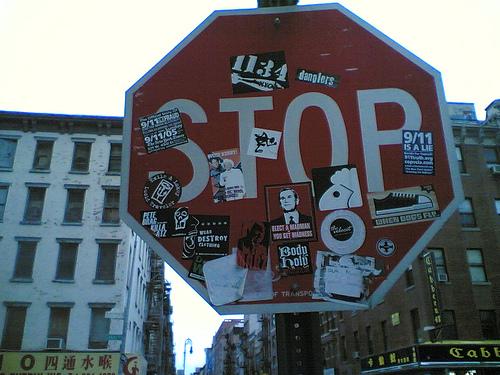How many stickers are on the sign?
Be succinct. 18. Are people using this stop sign as an advertising board?
Quick response, please. Yes. Is this sign's current condition a result of a city mandate?
Give a very brief answer. No. 